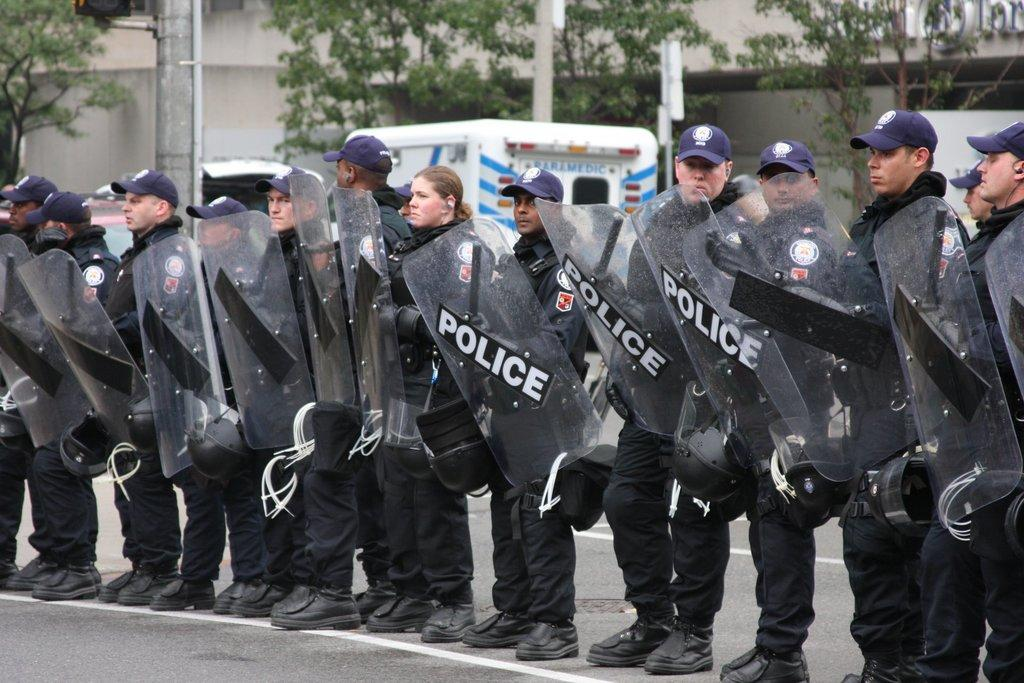What type of people can be seen in the image? There is a group of policemen in the image. What position are the policemen in? The policemen are standing in the image. What headgear are the policemen wearing? The policemen are wearing caps in the image. What objects are the policemen holding? The policemen are holding shields in their hands in the image. What can be seen in the background of the image? There are vehicles, trees, poles, and a wall in the background of the image. What type of arithmetic problem can be solved using the shields held by the policemen in the image? There is no arithmetic problem present in the image, as the shields are not related to solving mathematical equations. 